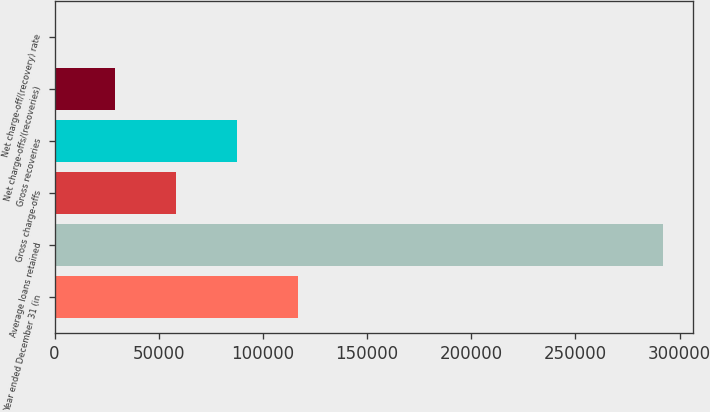Convert chart. <chart><loc_0><loc_0><loc_500><loc_500><bar_chart><fcel>Year ended December 31 (in<fcel>Average loans retained<fcel>Gross charge-offs<fcel>Gross recoveries<fcel>Net charge-offs/(recoveries)<fcel>Net charge-off/(recovery) rate<nl><fcel>116792<fcel>291980<fcel>58396<fcel>87594<fcel>29198<fcel>0.06<nl></chart> 